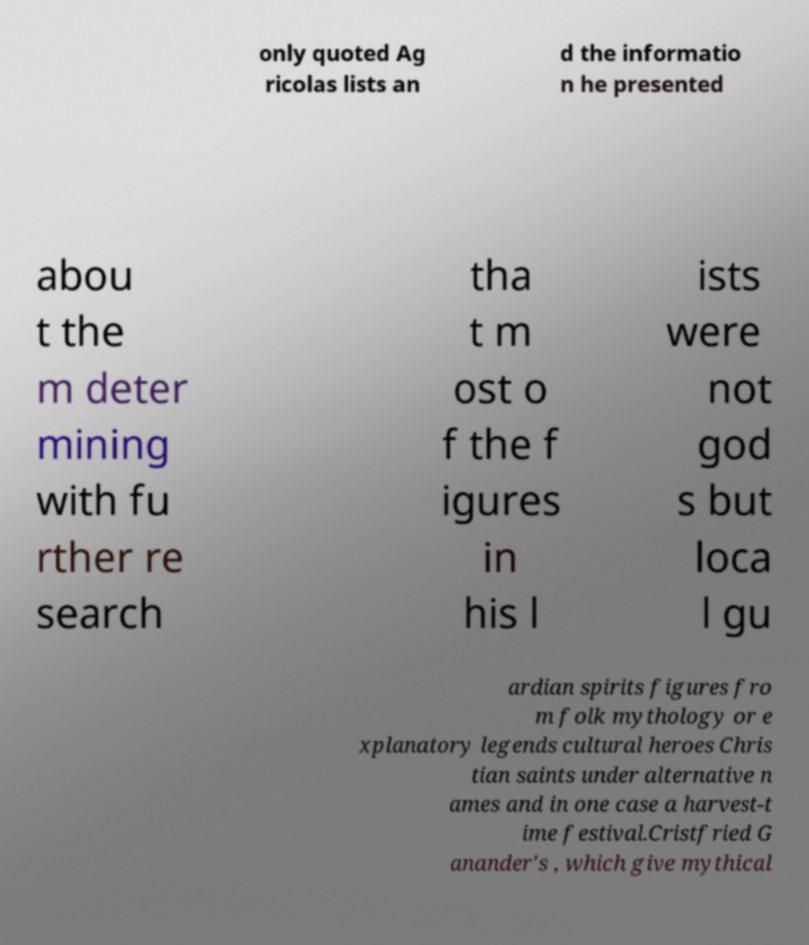Can you accurately transcribe the text from the provided image for me? only quoted Ag ricolas lists an d the informatio n he presented abou t the m deter mining with fu rther re search tha t m ost o f the f igures in his l ists were not god s but loca l gu ardian spirits figures fro m folk mythology or e xplanatory legends cultural heroes Chris tian saints under alternative n ames and in one case a harvest-t ime festival.Cristfried G anander's , which give mythical 